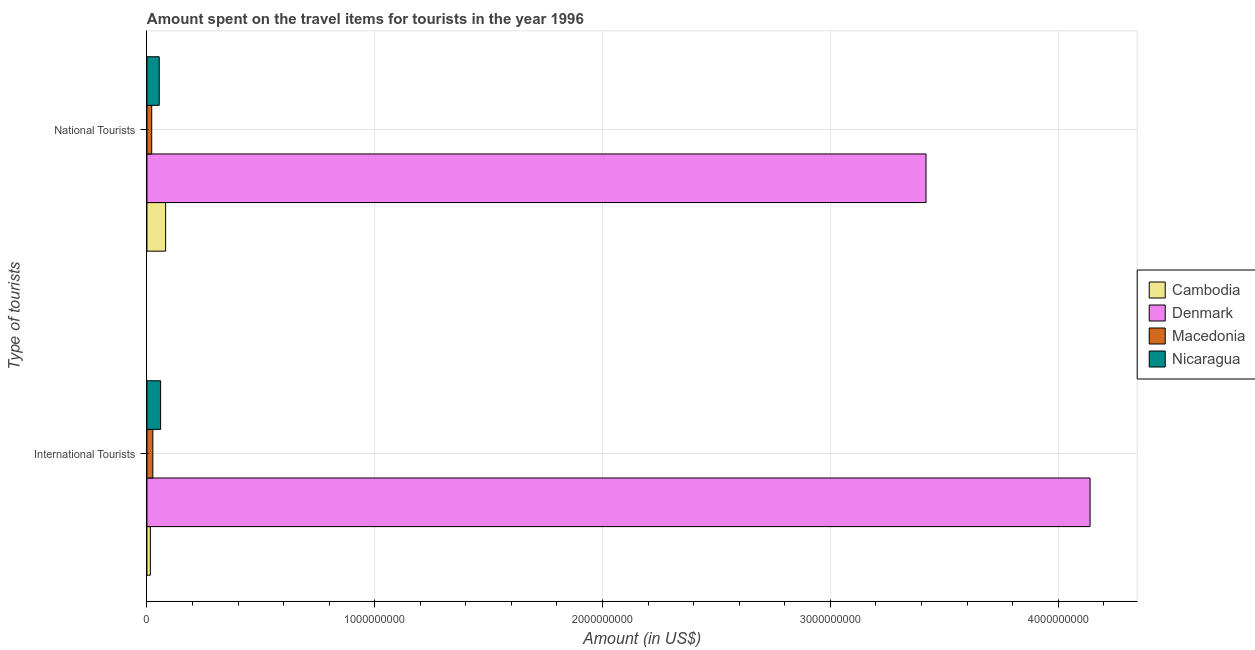What is the label of the 2nd group of bars from the top?
Provide a short and direct response. International Tourists. What is the amount spent on travel items of national tourists in Cambodia?
Offer a very short reply. 8.20e+07. Across all countries, what is the maximum amount spent on travel items of national tourists?
Your answer should be compact. 3.42e+09. Across all countries, what is the minimum amount spent on travel items of national tourists?
Your answer should be very brief. 2.10e+07. In which country was the amount spent on travel items of national tourists minimum?
Your answer should be very brief. Macedonia. What is the total amount spent on travel items of national tourists in the graph?
Ensure brevity in your answer.  3.58e+09. What is the difference between the amount spent on travel items of international tourists in Macedonia and that in Denmark?
Make the answer very short. -4.11e+09. What is the difference between the amount spent on travel items of international tourists in Nicaragua and the amount spent on travel items of national tourists in Macedonia?
Offer a terse response. 3.90e+07. What is the average amount spent on travel items of national tourists per country?
Provide a short and direct response. 8.94e+08. What is the difference between the amount spent on travel items of international tourists and amount spent on travel items of national tourists in Nicaragua?
Keep it short and to the point. 6.00e+06. What is the ratio of the amount spent on travel items of international tourists in Cambodia to that in Macedonia?
Provide a succinct answer. 0.58. In how many countries, is the amount spent on travel items of international tourists greater than the average amount spent on travel items of international tourists taken over all countries?
Provide a succinct answer. 1. What does the 4th bar from the top in National Tourists represents?
Make the answer very short. Cambodia. What does the 3rd bar from the bottom in National Tourists represents?
Your response must be concise. Macedonia. Are all the bars in the graph horizontal?
Provide a succinct answer. Yes. How many countries are there in the graph?
Your answer should be very brief. 4. What is the difference between two consecutive major ticks on the X-axis?
Provide a short and direct response. 1.00e+09. Does the graph contain grids?
Provide a short and direct response. Yes. Where does the legend appear in the graph?
Make the answer very short. Center right. How many legend labels are there?
Offer a terse response. 4. How are the legend labels stacked?
Offer a terse response. Vertical. What is the title of the graph?
Offer a terse response. Amount spent on the travel items for tourists in the year 1996. What is the label or title of the Y-axis?
Provide a short and direct response. Type of tourists. What is the Amount (in US$) in Cambodia in International Tourists?
Ensure brevity in your answer.  1.50e+07. What is the Amount (in US$) of Denmark in International Tourists?
Offer a very short reply. 4.14e+09. What is the Amount (in US$) of Macedonia in International Tourists?
Your answer should be very brief. 2.60e+07. What is the Amount (in US$) in Nicaragua in International Tourists?
Your answer should be very brief. 6.00e+07. What is the Amount (in US$) of Cambodia in National Tourists?
Provide a short and direct response. 8.20e+07. What is the Amount (in US$) of Denmark in National Tourists?
Make the answer very short. 3.42e+09. What is the Amount (in US$) of Macedonia in National Tourists?
Offer a very short reply. 2.10e+07. What is the Amount (in US$) of Nicaragua in National Tourists?
Your answer should be very brief. 5.40e+07. Across all Type of tourists, what is the maximum Amount (in US$) of Cambodia?
Provide a succinct answer. 8.20e+07. Across all Type of tourists, what is the maximum Amount (in US$) of Denmark?
Keep it short and to the point. 4.14e+09. Across all Type of tourists, what is the maximum Amount (in US$) of Macedonia?
Your answer should be compact. 2.60e+07. Across all Type of tourists, what is the maximum Amount (in US$) of Nicaragua?
Ensure brevity in your answer.  6.00e+07. Across all Type of tourists, what is the minimum Amount (in US$) of Cambodia?
Keep it short and to the point. 1.50e+07. Across all Type of tourists, what is the minimum Amount (in US$) in Denmark?
Offer a very short reply. 3.42e+09. Across all Type of tourists, what is the minimum Amount (in US$) of Macedonia?
Your answer should be compact. 2.10e+07. Across all Type of tourists, what is the minimum Amount (in US$) in Nicaragua?
Your answer should be compact. 5.40e+07. What is the total Amount (in US$) in Cambodia in the graph?
Keep it short and to the point. 9.70e+07. What is the total Amount (in US$) in Denmark in the graph?
Your response must be concise. 7.56e+09. What is the total Amount (in US$) of Macedonia in the graph?
Offer a terse response. 4.70e+07. What is the total Amount (in US$) of Nicaragua in the graph?
Make the answer very short. 1.14e+08. What is the difference between the Amount (in US$) in Cambodia in International Tourists and that in National Tourists?
Give a very brief answer. -6.70e+07. What is the difference between the Amount (in US$) in Denmark in International Tourists and that in National Tourists?
Offer a terse response. 7.20e+08. What is the difference between the Amount (in US$) of Macedonia in International Tourists and that in National Tourists?
Your answer should be compact. 5.00e+06. What is the difference between the Amount (in US$) of Nicaragua in International Tourists and that in National Tourists?
Your answer should be very brief. 6.00e+06. What is the difference between the Amount (in US$) of Cambodia in International Tourists and the Amount (in US$) of Denmark in National Tourists?
Ensure brevity in your answer.  -3.40e+09. What is the difference between the Amount (in US$) in Cambodia in International Tourists and the Amount (in US$) in Macedonia in National Tourists?
Your response must be concise. -6.00e+06. What is the difference between the Amount (in US$) of Cambodia in International Tourists and the Amount (in US$) of Nicaragua in National Tourists?
Offer a very short reply. -3.90e+07. What is the difference between the Amount (in US$) of Denmark in International Tourists and the Amount (in US$) of Macedonia in National Tourists?
Offer a very short reply. 4.12e+09. What is the difference between the Amount (in US$) of Denmark in International Tourists and the Amount (in US$) of Nicaragua in National Tourists?
Provide a short and direct response. 4.09e+09. What is the difference between the Amount (in US$) of Macedonia in International Tourists and the Amount (in US$) of Nicaragua in National Tourists?
Provide a succinct answer. -2.80e+07. What is the average Amount (in US$) in Cambodia per Type of tourists?
Make the answer very short. 4.85e+07. What is the average Amount (in US$) of Denmark per Type of tourists?
Your answer should be compact. 3.78e+09. What is the average Amount (in US$) in Macedonia per Type of tourists?
Your response must be concise. 2.35e+07. What is the average Amount (in US$) of Nicaragua per Type of tourists?
Your response must be concise. 5.70e+07. What is the difference between the Amount (in US$) of Cambodia and Amount (in US$) of Denmark in International Tourists?
Provide a succinct answer. -4.12e+09. What is the difference between the Amount (in US$) of Cambodia and Amount (in US$) of Macedonia in International Tourists?
Offer a very short reply. -1.10e+07. What is the difference between the Amount (in US$) of Cambodia and Amount (in US$) of Nicaragua in International Tourists?
Offer a terse response. -4.50e+07. What is the difference between the Amount (in US$) of Denmark and Amount (in US$) of Macedonia in International Tourists?
Give a very brief answer. 4.11e+09. What is the difference between the Amount (in US$) in Denmark and Amount (in US$) in Nicaragua in International Tourists?
Provide a short and direct response. 4.08e+09. What is the difference between the Amount (in US$) of Macedonia and Amount (in US$) of Nicaragua in International Tourists?
Make the answer very short. -3.40e+07. What is the difference between the Amount (in US$) in Cambodia and Amount (in US$) in Denmark in National Tourists?
Give a very brief answer. -3.34e+09. What is the difference between the Amount (in US$) of Cambodia and Amount (in US$) of Macedonia in National Tourists?
Provide a short and direct response. 6.10e+07. What is the difference between the Amount (in US$) in Cambodia and Amount (in US$) in Nicaragua in National Tourists?
Give a very brief answer. 2.80e+07. What is the difference between the Amount (in US$) of Denmark and Amount (in US$) of Macedonia in National Tourists?
Ensure brevity in your answer.  3.40e+09. What is the difference between the Amount (in US$) of Denmark and Amount (in US$) of Nicaragua in National Tourists?
Your answer should be compact. 3.37e+09. What is the difference between the Amount (in US$) of Macedonia and Amount (in US$) of Nicaragua in National Tourists?
Offer a very short reply. -3.30e+07. What is the ratio of the Amount (in US$) of Cambodia in International Tourists to that in National Tourists?
Provide a short and direct response. 0.18. What is the ratio of the Amount (in US$) in Denmark in International Tourists to that in National Tourists?
Offer a terse response. 1.21. What is the ratio of the Amount (in US$) of Macedonia in International Tourists to that in National Tourists?
Keep it short and to the point. 1.24. What is the ratio of the Amount (in US$) in Nicaragua in International Tourists to that in National Tourists?
Provide a succinct answer. 1.11. What is the difference between the highest and the second highest Amount (in US$) in Cambodia?
Ensure brevity in your answer.  6.70e+07. What is the difference between the highest and the second highest Amount (in US$) of Denmark?
Offer a terse response. 7.20e+08. What is the difference between the highest and the lowest Amount (in US$) of Cambodia?
Your answer should be compact. 6.70e+07. What is the difference between the highest and the lowest Amount (in US$) of Denmark?
Give a very brief answer. 7.20e+08. What is the difference between the highest and the lowest Amount (in US$) in Macedonia?
Offer a terse response. 5.00e+06. 